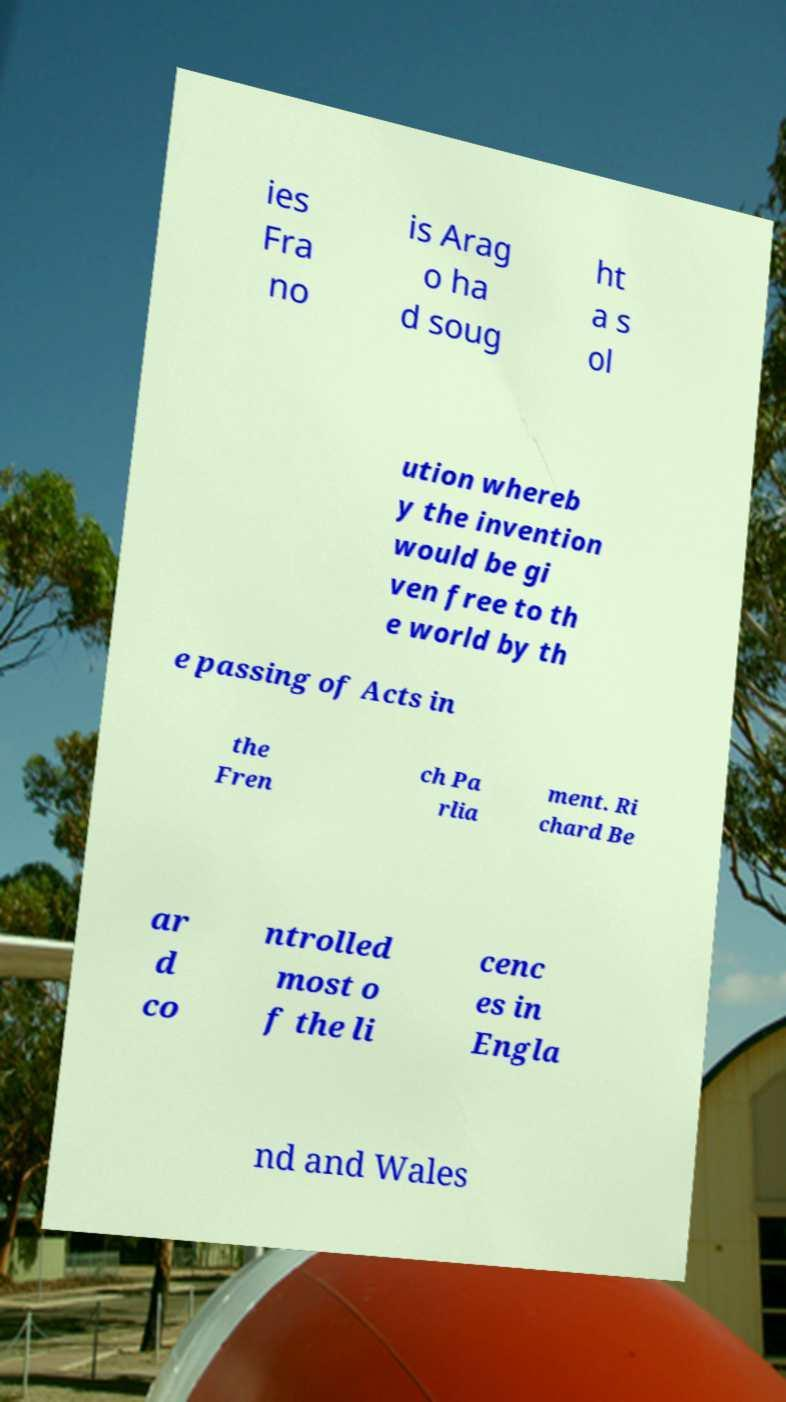Could you assist in decoding the text presented in this image and type it out clearly? ies Fra no is Arag o ha d soug ht a s ol ution whereb y the invention would be gi ven free to th e world by th e passing of Acts in the Fren ch Pa rlia ment. Ri chard Be ar d co ntrolled most o f the li cenc es in Engla nd and Wales 